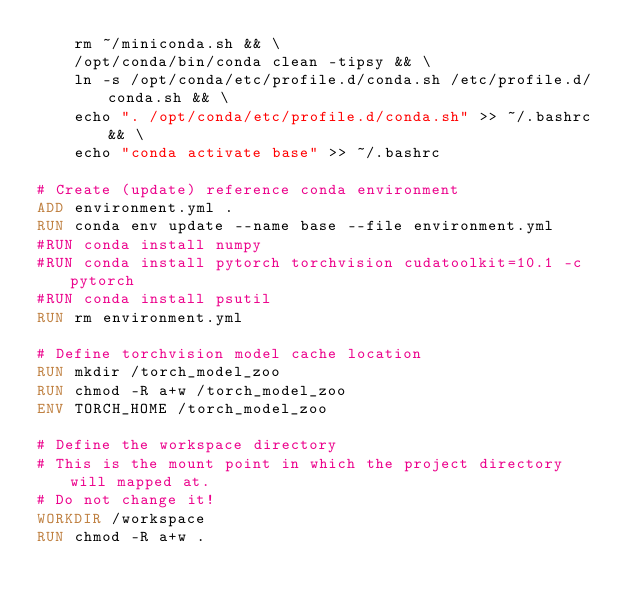Convert code to text. <code><loc_0><loc_0><loc_500><loc_500><_Dockerfile_>    rm ~/miniconda.sh && \
    /opt/conda/bin/conda clean -tipsy && \
    ln -s /opt/conda/etc/profile.d/conda.sh /etc/profile.d/conda.sh && \
    echo ". /opt/conda/etc/profile.d/conda.sh" >> ~/.bashrc && \
    echo "conda activate base" >> ~/.bashrc

# Create (update) reference conda environment
ADD environment.yml .
RUN conda env update --name base --file environment.yml
#RUN conda install numpy
#RUN conda install pytorch torchvision cudatoolkit=10.1 -c pytorch
#RUN conda install psutil
RUN rm environment.yml

# Define torchvision model cache location
RUN mkdir /torch_model_zoo
RUN chmod -R a+w /torch_model_zoo
ENV TORCH_HOME /torch_model_zoo

# Define the workspace directory
# This is the mount point in which the project directory will mapped at.
# Do not change it!
WORKDIR /workspace
RUN chmod -R a+w .</code> 